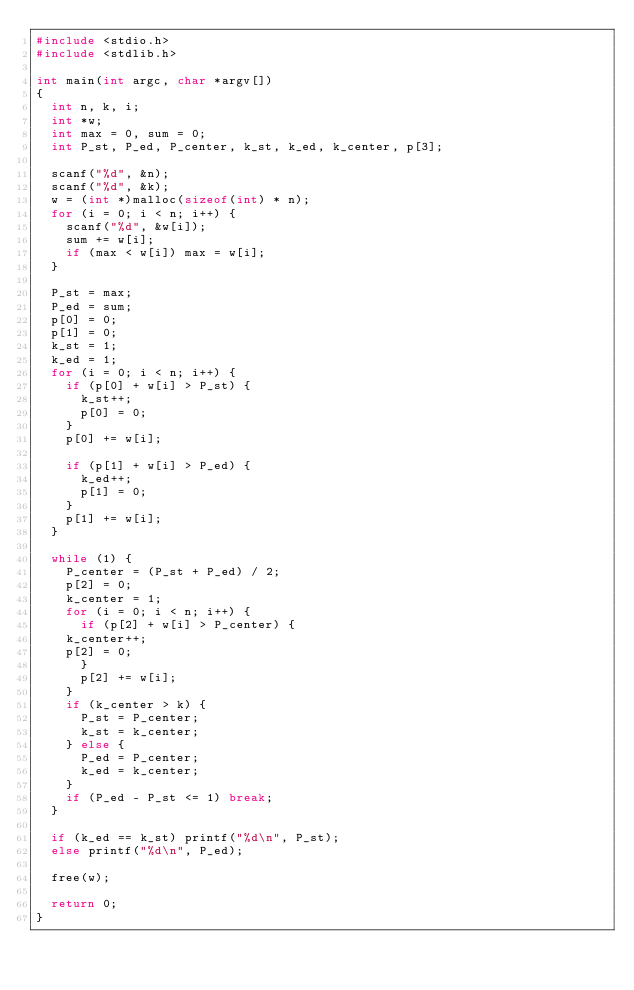Convert code to text. <code><loc_0><loc_0><loc_500><loc_500><_C_>#include <stdio.h>
#include <stdlib.h>

int main(int argc, char *argv[])
{
  int n, k, i;
  int *w;
  int max = 0, sum = 0;
  int P_st, P_ed, P_center, k_st, k_ed, k_center, p[3];

  scanf("%d", &n);
  scanf("%d", &k);
  w = (int *)malloc(sizeof(int) * n);
  for (i = 0; i < n; i++) {
    scanf("%d", &w[i]);
    sum += w[i];
    if (max < w[i]) max = w[i];
  }

  P_st = max;
  P_ed = sum;
  p[0] = 0;
  p[1] = 0;
  k_st = 1;
  k_ed = 1;
  for (i = 0; i < n; i++) {
    if (p[0] + w[i] > P_st) {
      k_st++;
      p[0] = 0;
    }
    p[0] += w[i];

    if (p[1] + w[i] > P_ed) {
      k_ed++;
      p[1] = 0;
    }
    p[1] += w[i];
  }

  while (1) {
    P_center = (P_st + P_ed) / 2;
    p[2] = 0;
    k_center = 1;
    for (i = 0; i < n; i++) {
      if (p[2] + w[i] > P_center) {
	k_center++;
	p[2] = 0;
      }
      p[2] += w[i];
    }
    if (k_center > k) {
      P_st = P_center;
      k_st = k_center;
    } else {
      P_ed = P_center;
      k_ed = k_center;
    }
    if (P_ed - P_st <= 1) break;
  }

  if (k_ed == k_st) printf("%d\n", P_st);
  else printf("%d\n", P_ed);

  free(w);

  return 0;
}</code> 